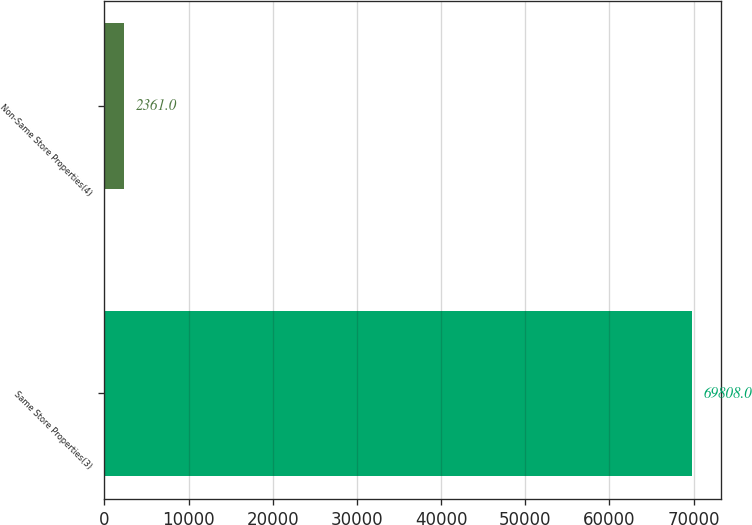<chart> <loc_0><loc_0><loc_500><loc_500><bar_chart><fcel>Same Store Properties(3)<fcel>Non-Same Store Properties(4)<nl><fcel>69808<fcel>2361<nl></chart> 